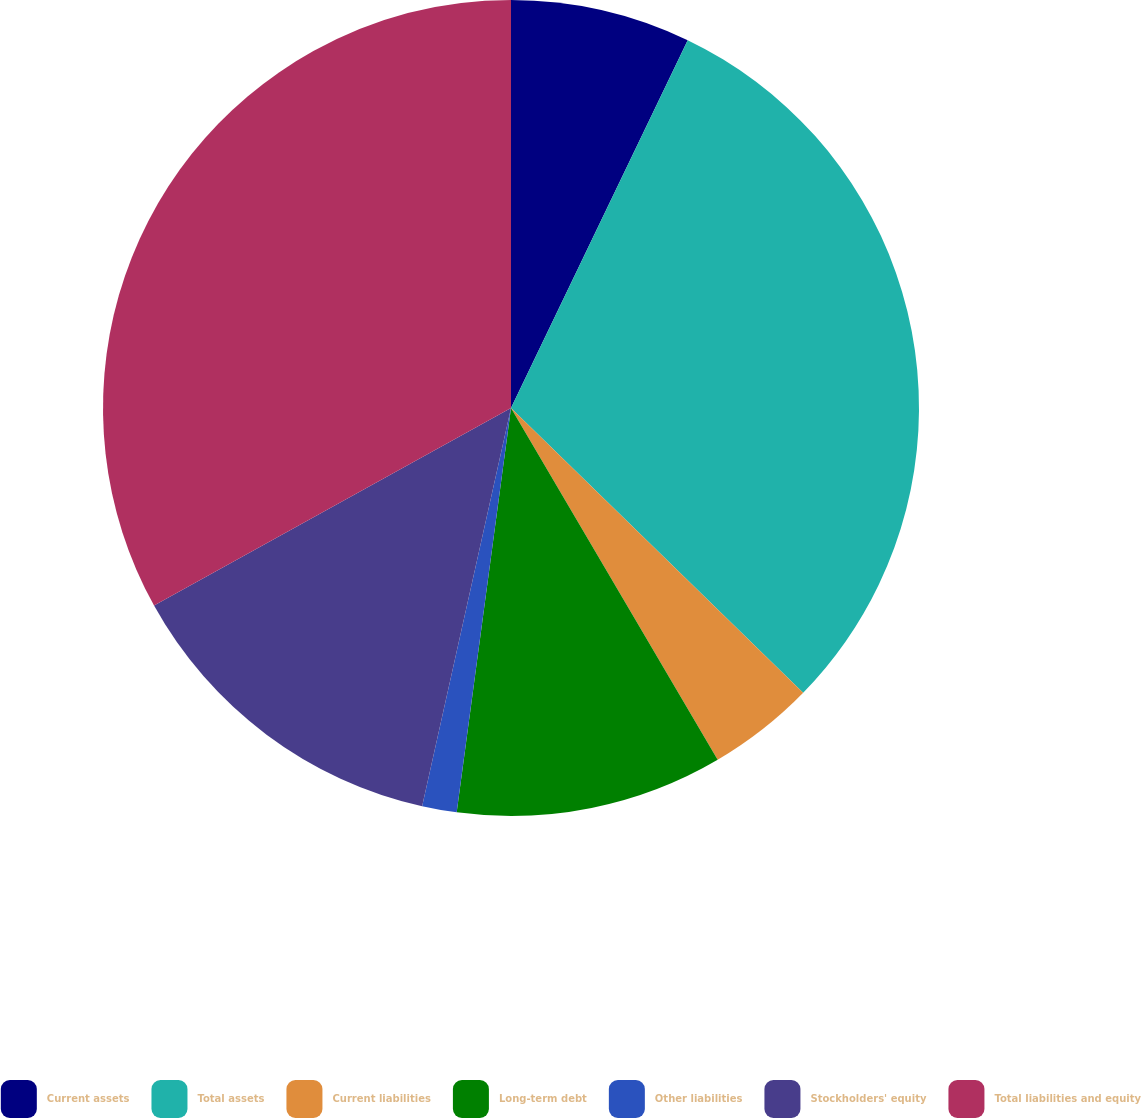<chart> <loc_0><loc_0><loc_500><loc_500><pie_chart><fcel>Current assets<fcel>Total assets<fcel>Current liabilities<fcel>Long-term debt<fcel>Other liabilities<fcel>Stockholders' equity<fcel>Total liabilities and equity<nl><fcel>7.13%<fcel>30.17%<fcel>4.25%<fcel>10.58%<fcel>1.37%<fcel>13.46%<fcel>33.05%<nl></chart> 